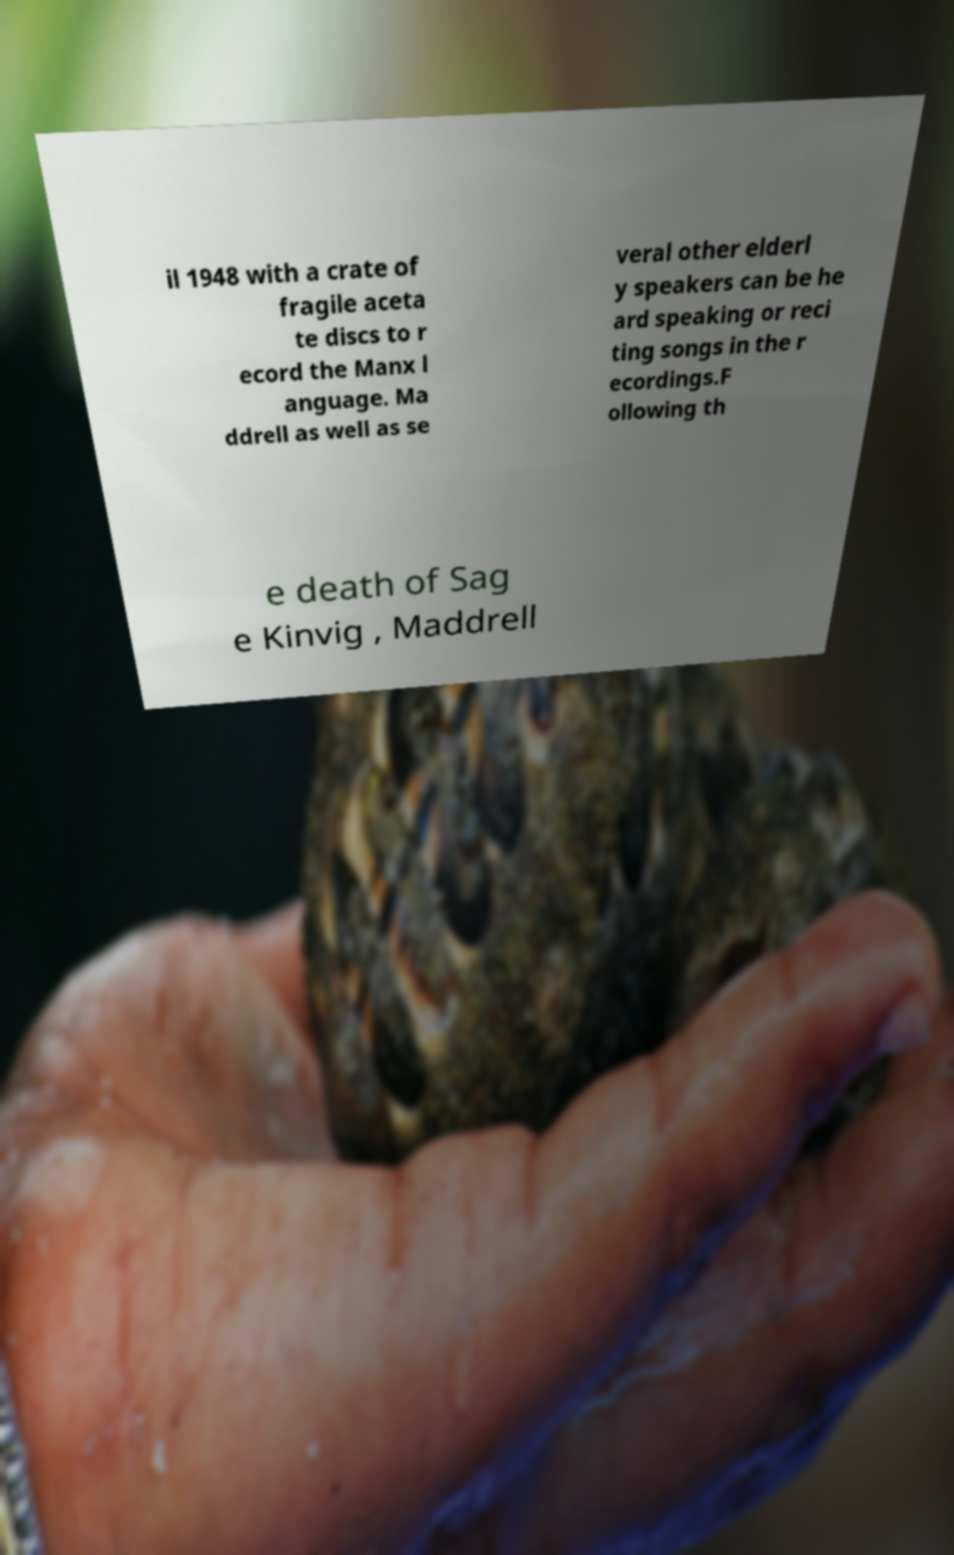Please read and relay the text visible in this image. What does it say? il 1948 with a crate of fragile aceta te discs to r ecord the Manx l anguage. Ma ddrell as well as se veral other elderl y speakers can be he ard speaking or reci ting songs in the r ecordings.F ollowing th e death of Sag e Kinvig , Maddrell 